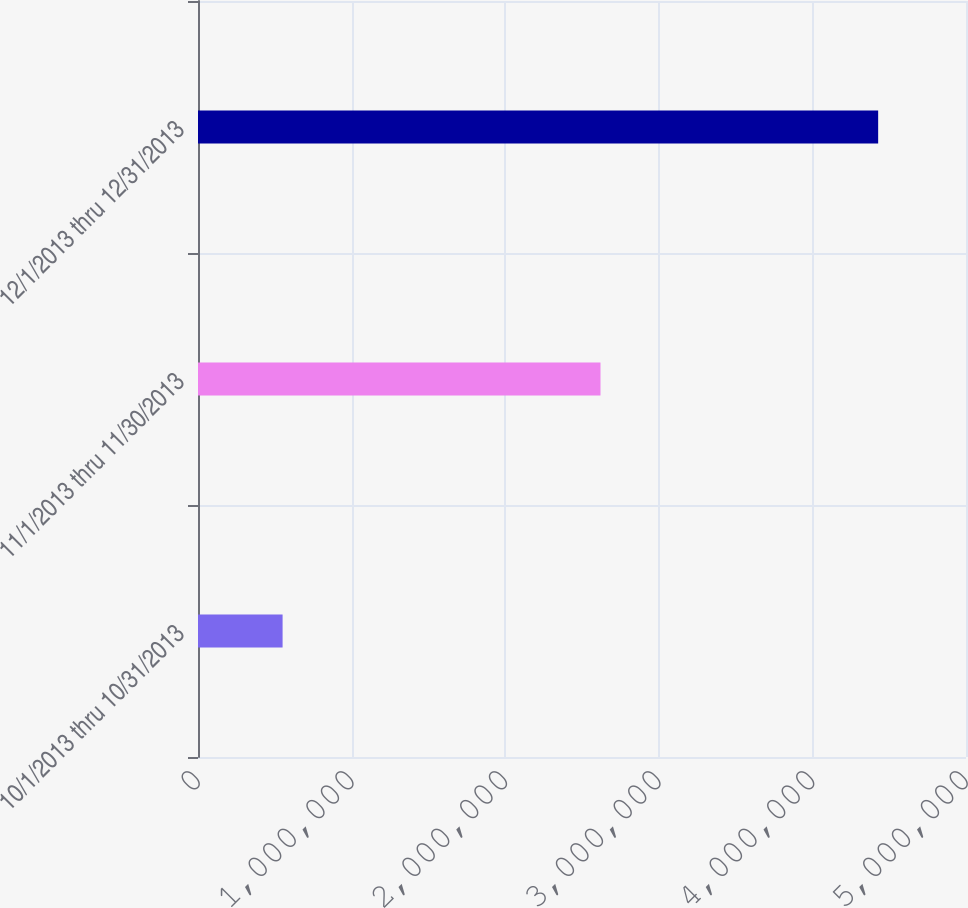Convert chart. <chart><loc_0><loc_0><loc_500><loc_500><bar_chart><fcel>10/1/2013 thru 10/31/2013<fcel>11/1/2013 thru 11/30/2013<fcel>12/1/2013 thru 12/31/2013<nl><fcel>550733<fcel>2.62046e+06<fcel>4.42811e+06<nl></chart> 